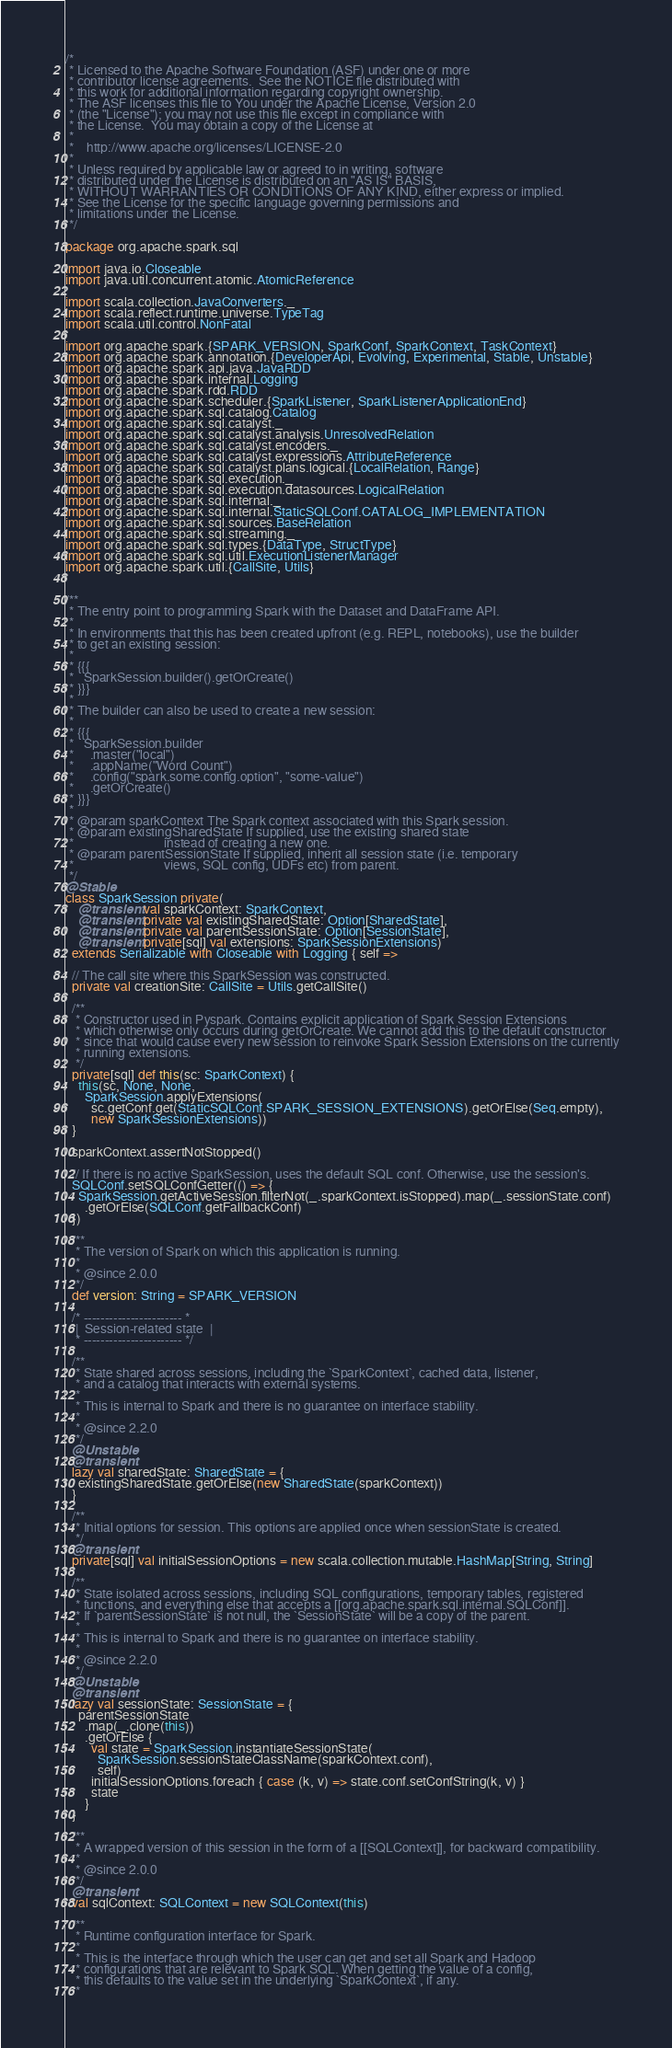Convert code to text. <code><loc_0><loc_0><loc_500><loc_500><_Scala_>/*
 * Licensed to the Apache Software Foundation (ASF) under one or more
 * contributor license agreements.  See the NOTICE file distributed with
 * this work for additional information regarding copyright ownership.
 * The ASF licenses this file to You under the Apache License, Version 2.0
 * (the "License"); you may not use this file except in compliance with
 * the License.  You may obtain a copy of the License at
 *
 *    http://www.apache.org/licenses/LICENSE-2.0
 *
 * Unless required by applicable law or agreed to in writing, software
 * distributed under the License is distributed on an "AS IS" BASIS,
 * WITHOUT WARRANTIES OR CONDITIONS OF ANY KIND, either express or implied.
 * See the License for the specific language governing permissions and
 * limitations under the License.
 */

package org.apache.spark.sql

import java.io.Closeable
import java.util.concurrent.atomic.AtomicReference

import scala.collection.JavaConverters._
import scala.reflect.runtime.universe.TypeTag
import scala.util.control.NonFatal

import org.apache.spark.{SPARK_VERSION, SparkConf, SparkContext, TaskContext}
import org.apache.spark.annotation.{DeveloperApi, Evolving, Experimental, Stable, Unstable}
import org.apache.spark.api.java.JavaRDD
import org.apache.spark.internal.Logging
import org.apache.spark.rdd.RDD
import org.apache.spark.scheduler.{SparkListener, SparkListenerApplicationEnd}
import org.apache.spark.sql.catalog.Catalog
import org.apache.spark.sql.catalyst._
import org.apache.spark.sql.catalyst.analysis.UnresolvedRelation
import org.apache.spark.sql.catalyst.encoders._
import org.apache.spark.sql.catalyst.expressions.AttributeReference
import org.apache.spark.sql.catalyst.plans.logical.{LocalRelation, Range}
import org.apache.spark.sql.execution._
import org.apache.spark.sql.execution.datasources.LogicalRelation
import org.apache.spark.sql.internal._
import org.apache.spark.sql.internal.StaticSQLConf.CATALOG_IMPLEMENTATION
import org.apache.spark.sql.sources.BaseRelation
import org.apache.spark.sql.streaming._
import org.apache.spark.sql.types.{DataType, StructType}
import org.apache.spark.sql.util.ExecutionListenerManager
import org.apache.spark.util.{CallSite, Utils}


/**
 * The entry point to programming Spark with the Dataset and DataFrame API.
 *
 * In environments that this has been created upfront (e.g. REPL, notebooks), use the builder
 * to get an existing session:
 *
 * {{{
 *   SparkSession.builder().getOrCreate()
 * }}}
 *
 * The builder can also be used to create a new session:
 *
 * {{{
 *   SparkSession.builder
 *     .master("local")
 *     .appName("Word Count")
 *     .config("spark.some.config.option", "some-value")
 *     .getOrCreate()
 * }}}
 *
 * @param sparkContext The Spark context associated with this Spark session.
 * @param existingSharedState If supplied, use the existing shared state
 *                            instead of creating a new one.
 * @param parentSessionState If supplied, inherit all session state (i.e. temporary
 *                            views, SQL config, UDFs etc) from parent.
 */
@Stable
class SparkSession private(
    @transient val sparkContext: SparkContext,
    @transient private val existingSharedState: Option[SharedState],
    @transient private val parentSessionState: Option[SessionState],
    @transient private[sql] val extensions: SparkSessionExtensions)
  extends Serializable with Closeable with Logging { self =>

  // The call site where this SparkSession was constructed.
  private val creationSite: CallSite = Utils.getCallSite()

  /**
   * Constructor used in Pyspark. Contains explicit application of Spark Session Extensions
   * which otherwise only occurs during getOrCreate. We cannot add this to the default constructor
   * since that would cause every new session to reinvoke Spark Session Extensions on the currently
   * running extensions.
   */
  private[sql] def this(sc: SparkContext) {
    this(sc, None, None,
      SparkSession.applyExtensions(
        sc.getConf.get(StaticSQLConf.SPARK_SESSION_EXTENSIONS).getOrElse(Seq.empty),
        new SparkSessionExtensions))
  }

  sparkContext.assertNotStopped()

  // If there is no active SparkSession, uses the default SQL conf. Otherwise, use the session's.
  SQLConf.setSQLConfGetter(() => {
    SparkSession.getActiveSession.filterNot(_.sparkContext.isStopped).map(_.sessionState.conf)
      .getOrElse(SQLConf.getFallbackConf)
  })

  /**
   * The version of Spark on which this application is running.
   *
   * @since 2.0.0
   */
  def version: String = SPARK_VERSION

  /* ----------------------- *
   |  Session-related state  |
   * ----------------------- */

  /**
   * State shared across sessions, including the `SparkContext`, cached data, listener,
   * and a catalog that interacts with external systems.
   *
   * This is internal to Spark and there is no guarantee on interface stability.
   *
   * @since 2.2.0
   */
  @Unstable
  @transient
  lazy val sharedState: SharedState = {
    existingSharedState.getOrElse(new SharedState(sparkContext))
  }

  /**
   * Initial options for session. This options are applied once when sessionState is created.
   */
  @transient
  private[sql] val initialSessionOptions = new scala.collection.mutable.HashMap[String, String]

  /**
   * State isolated across sessions, including SQL configurations, temporary tables, registered
   * functions, and everything else that accepts a [[org.apache.spark.sql.internal.SQLConf]].
   * If `parentSessionState` is not null, the `SessionState` will be a copy of the parent.
   *
   * This is internal to Spark and there is no guarantee on interface stability.
   *
   * @since 2.2.0
   */
  @Unstable
  @transient
  lazy val sessionState: SessionState = {
    parentSessionState
      .map(_.clone(this))
      .getOrElse {
        val state = SparkSession.instantiateSessionState(
          SparkSession.sessionStateClassName(sparkContext.conf),
          self)
        initialSessionOptions.foreach { case (k, v) => state.conf.setConfString(k, v) }
        state
      }
  }

  /**
   * A wrapped version of this session in the form of a [[SQLContext]], for backward compatibility.
   *
   * @since 2.0.0
   */
  @transient
  val sqlContext: SQLContext = new SQLContext(this)

  /**
   * Runtime configuration interface for Spark.
   *
   * This is the interface through which the user can get and set all Spark and Hadoop
   * configurations that are relevant to Spark SQL. When getting the value of a config,
   * this defaults to the value set in the underlying `SparkContext`, if any.
   *</code> 